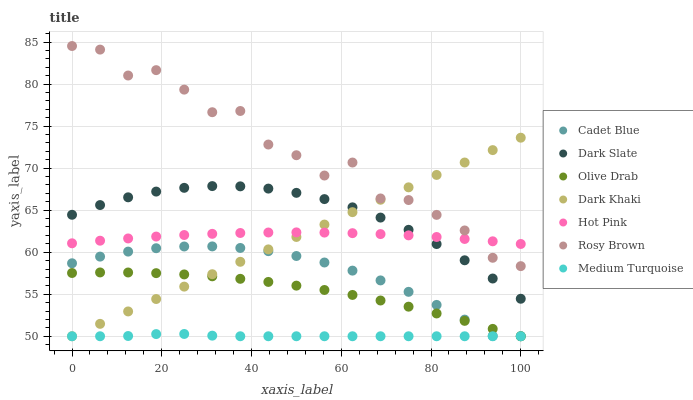Does Medium Turquoise have the minimum area under the curve?
Answer yes or no. Yes. Does Rosy Brown have the maximum area under the curve?
Answer yes or no. Yes. Does Dark Khaki have the minimum area under the curve?
Answer yes or no. No. Does Dark Khaki have the maximum area under the curve?
Answer yes or no. No. Is Dark Khaki the smoothest?
Answer yes or no. Yes. Is Rosy Brown the roughest?
Answer yes or no. Yes. Is Rosy Brown the smoothest?
Answer yes or no. No. Is Dark Khaki the roughest?
Answer yes or no. No. Does Cadet Blue have the lowest value?
Answer yes or no. Yes. Does Rosy Brown have the lowest value?
Answer yes or no. No. Does Rosy Brown have the highest value?
Answer yes or no. Yes. Does Dark Khaki have the highest value?
Answer yes or no. No. Is Medium Turquoise less than Dark Slate?
Answer yes or no. Yes. Is Dark Slate greater than Medium Turquoise?
Answer yes or no. Yes. Does Dark Khaki intersect Hot Pink?
Answer yes or no. Yes. Is Dark Khaki less than Hot Pink?
Answer yes or no. No. Is Dark Khaki greater than Hot Pink?
Answer yes or no. No. Does Medium Turquoise intersect Dark Slate?
Answer yes or no. No. 